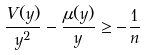Convert formula to latex. <formula><loc_0><loc_0><loc_500><loc_500>\frac { V ( y ) } { y ^ { 2 } } - \frac { \mu ( y ) } { y } \geq - \frac { 1 } { n }</formula> 